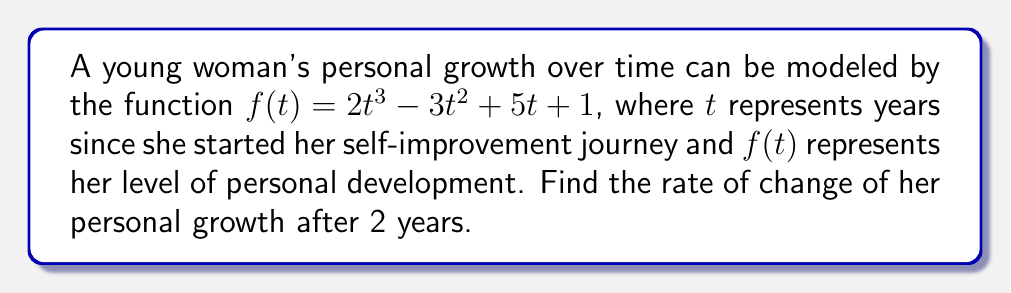Help me with this question. To find the rate of change of the curve representing personal growth, we need to calculate the derivative of the given function and then evaluate it at $t = 2$.

Step 1: Find the derivative of $f(t)$.
$f(t) = 2t^3 - 3t^2 + 5t + 1$
$f'(t) = \frac{d}{dt}(2t^3 - 3t^2 + 5t + 1)$
$f'(t) = 6t^2 - 6t + 5$

Step 2: Evaluate the derivative at $t = 2$.
$f'(2) = 6(2)^2 - 6(2) + 5$
$f'(2) = 6(4) - 12 + 5$
$f'(2) = 24 - 12 + 5$
$f'(2) = 17$

Therefore, the rate of change of her personal growth after 2 years is 17 units per year.
Answer: 17 units/year 